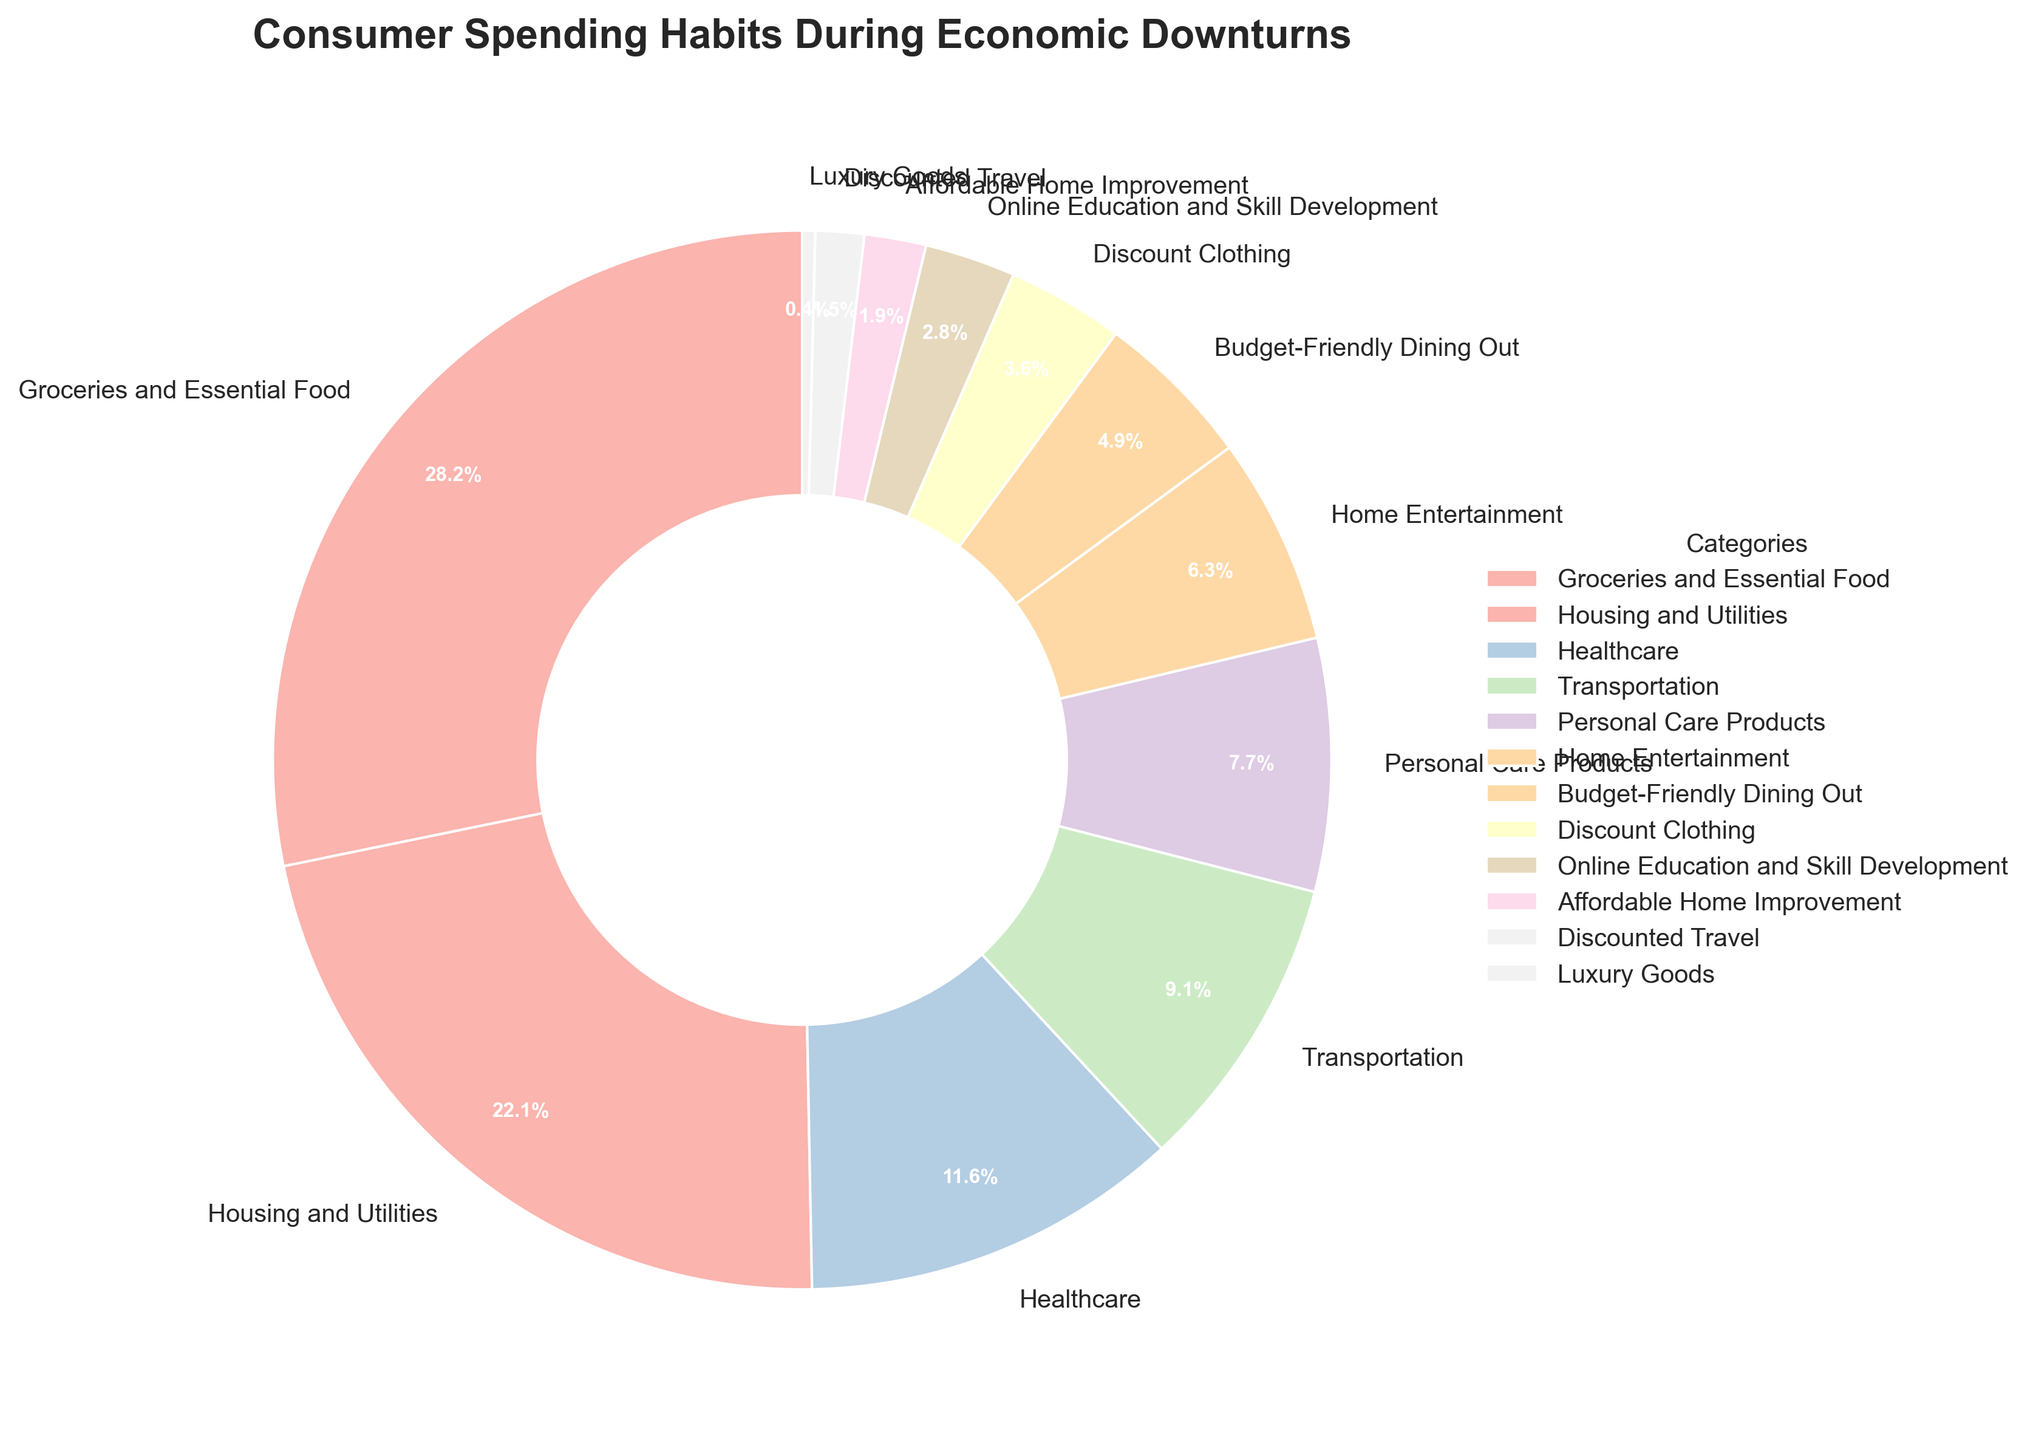What category takes up the largest percentage of consumer spending? By looking at the slices representing the different categories in the pie chart, the largest slice is labeled "Groceries and Essential Food".
Answer: Groceries and Essential Food Which category has a higher spending percentage, Transportation or Personal Care Products? By comparing the two slices, Transportation is represented by 9.2% and Personal Care Products is represented by 7.8%.
Answer: Transportation What is the combined spending percentage for Housing and Utilities and Healthcare? Adding the percentages of Housing and Utilities (22.3%) and Healthcare (11.7%) gives: 22.3% + 11.7% = 34%.
Answer: 34% Are there any categories with less than 2% spending? If so, which ones? By looking at the slices titled less than 2%, Affordable Home Improvement (1.9%) and Discounted Travel (1.5%) meet this criterion.
Answer: Affordable Home Improvement, Discounted Travel What's the difference in spending between Home Entertainment and Budget-Friendly Dining Out? Subtracting the percentage for Budget-Friendly Dining Out (4.9%) from Home Entertainment (6.4%) gives: 6.4% - 4.9% = 1.5%.
Answer: 1.5% How much more percentage is spent on Healthcare compared to Discount Clothing? Subtracting the percentage for Discount Clothing (3.6%) from Healthcare (11.7%) gives: 11.7% - 3.6% = 8.1%.
Answer: 8.1% Which category occupies the smallest slice of the pie chart? By identifying the smallest slice, Luxury Goods represents only 0.4%.
Answer: Luxury Goods What's the sum of the spending percentages for the three largest categories? Adding the three largest percentages: Groceries and Essential Food (28.5%), Housing and Utilities (22.3%), and Healthcare (11.7%) gives: 28.5% + 22.3% + 11.7% = 62.5%.
Answer: 62.5% Is there a noticeable difference in color for categories below 5% spending? Categories such as Discount Clothing, Online Education and Skill Development, Affordable Home Improvement, and Discounted Travel each have distinct colors but share the pastel scheme.
Answer: Yes How many categories have spending percentages between 5% and 10%? By counting the slices within the 5% to 10% range: Personal Care Products (7.8%), Home Entertainment (6.4%), and Transportation (9.2%) make three categories.
Answer: 3 